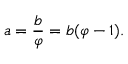<formula> <loc_0><loc_0><loc_500><loc_500>a = { \frac { b } { \varphi } } = b ( \varphi - 1 ) .</formula> 